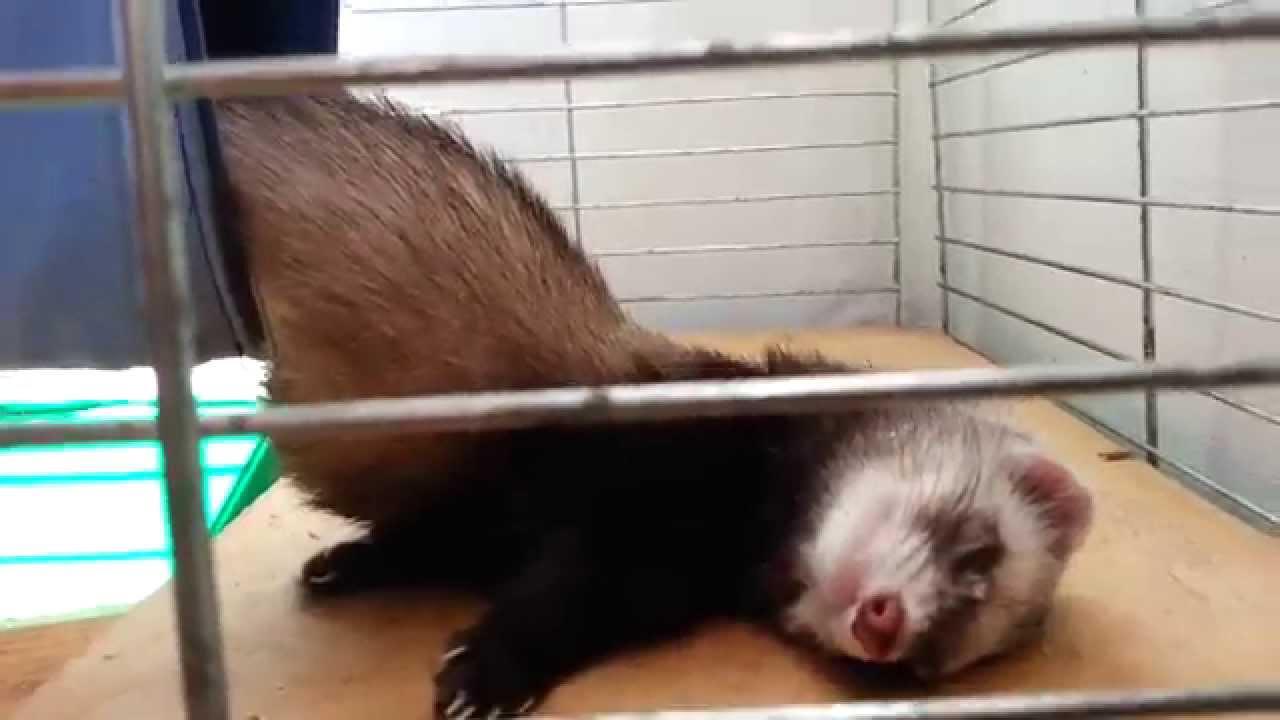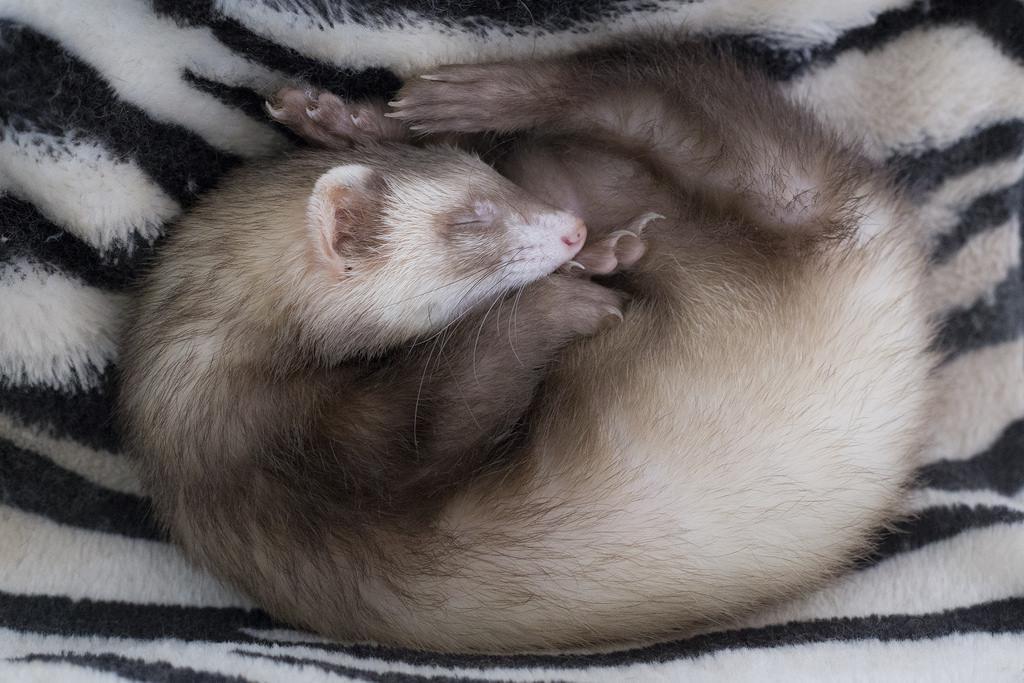The first image is the image on the left, the second image is the image on the right. For the images displayed, is the sentence "There is one ferret in the right image with its eyes closed." factually correct? Answer yes or no. Yes. The first image is the image on the left, the second image is the image on the right. Assess this claim about the two images: "There is at least one white ferreton a blanket with another ferret.". Correct or not? Answer yes or no. No. 